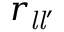Convert formula to latex. <formula><loc_0><loc_0><loc_500><loc_500>r _ { { l } { l } ^ { \prime } }</formula> 